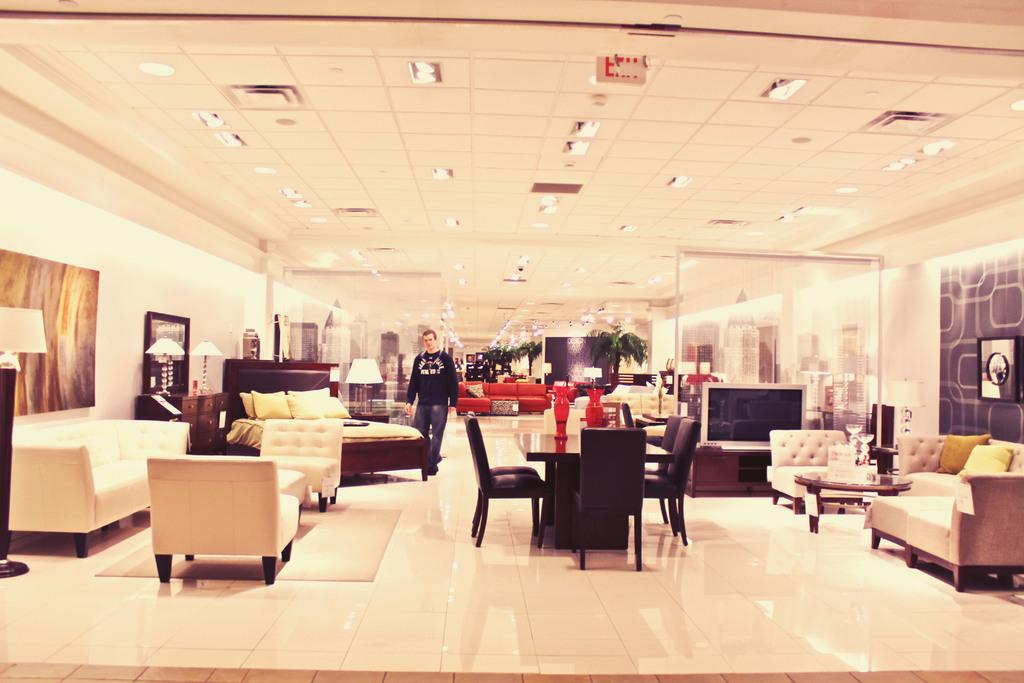What is the main subject in the image? There is a man standing in the image. What type of furniture can be found in the house? There are beds, a sofa, chairs, and a dining table in the house. What type of entertainment device is present in the house? There is a TV in the house. What can be seen outside the house? There are trees visible in the house. What route does the man take to reach the sofa in the image? The image does not show the man moving or taking a route to reach the sofa, so we cannot determine his path. 